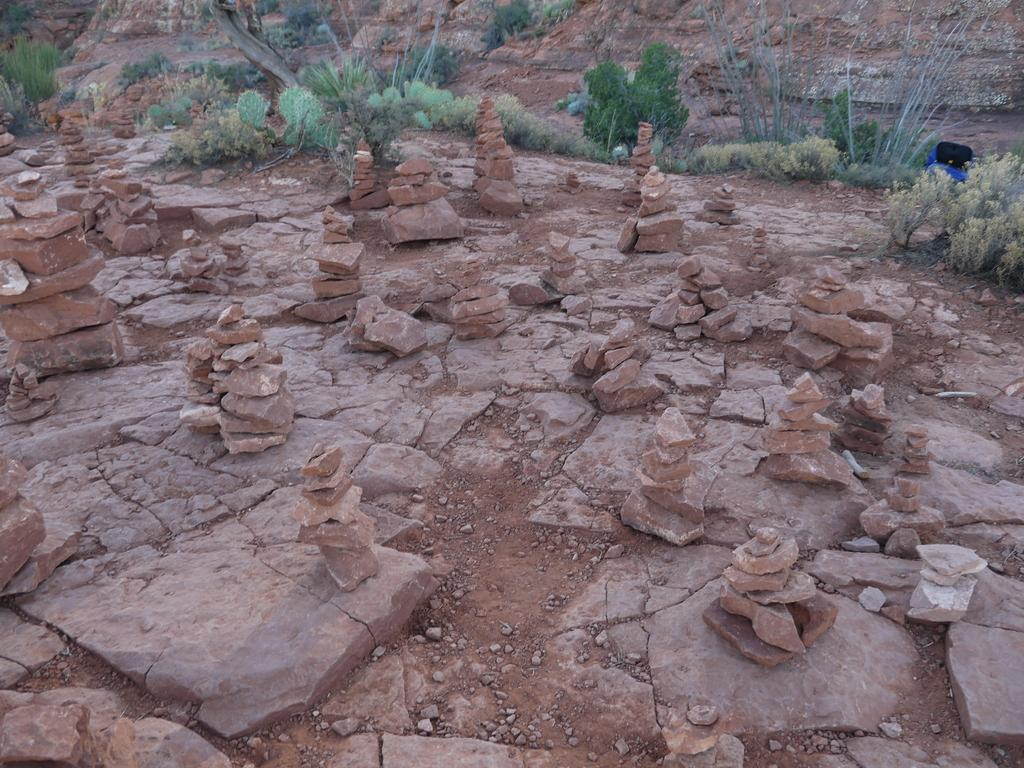What type of surface is visible on the ground in the image? There are stones present on the ground in the image. What other elements can be seen in the image besides the stones? There are plants present in the image. How many turkeys can be seen in the image? There are no turkeys present in the image. What is the level of the stones in the image? The level of the stones cannot be determined from the image alone, as it only shows their presence on the ground. 